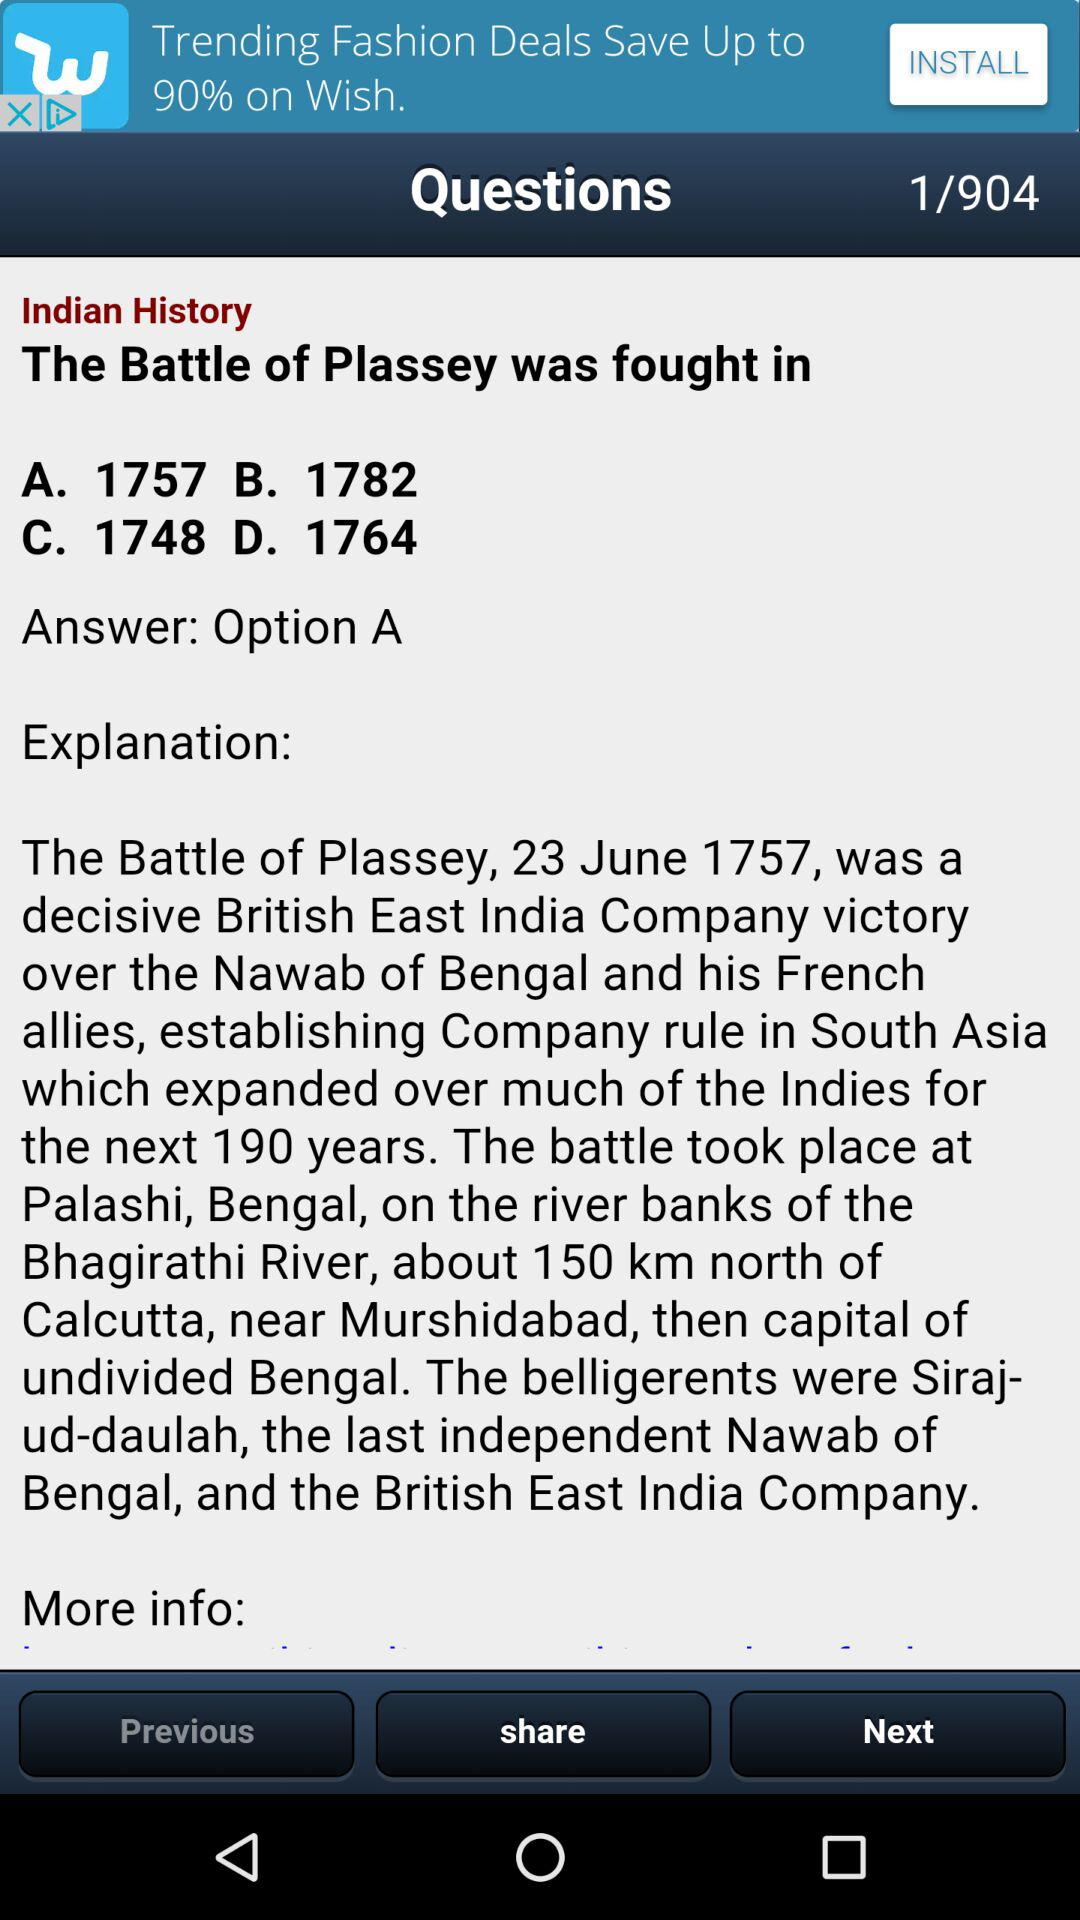Which question have I been asked? The question that you have been asked is "The Battle of Plassey was fought in". 